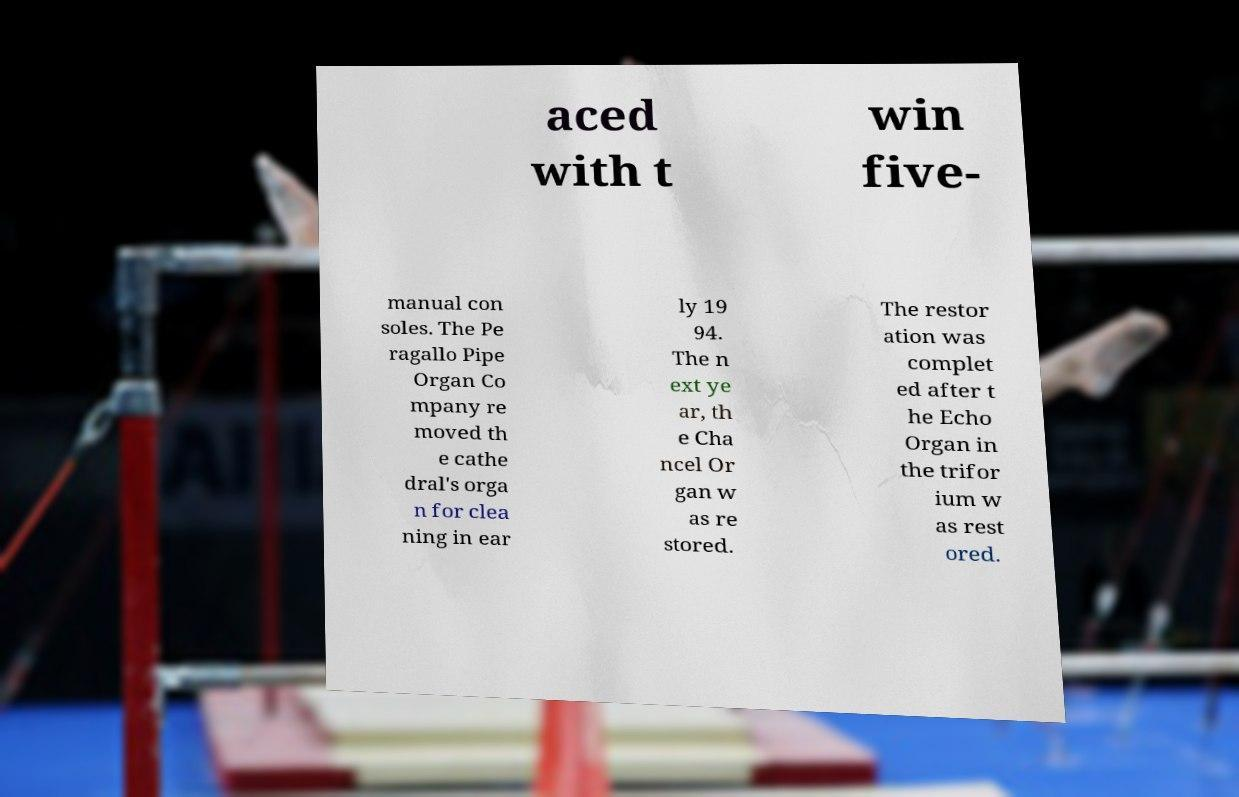Can you read and provide the text displayed in the image?This photo seems to have some interesting text. Can you extract and type it out for me? aced with t win five- manual con soles. The Pe ragallo Pipe Organ Co mpany re moved th e cathe dral's orga n for clea ning in ear ly 19 94. The n ext ye ar, th e Cha ncel Or gan w as re stored. The restor ation was complet ed after t he Echo Organ in the trifor ium w as rest ored. 